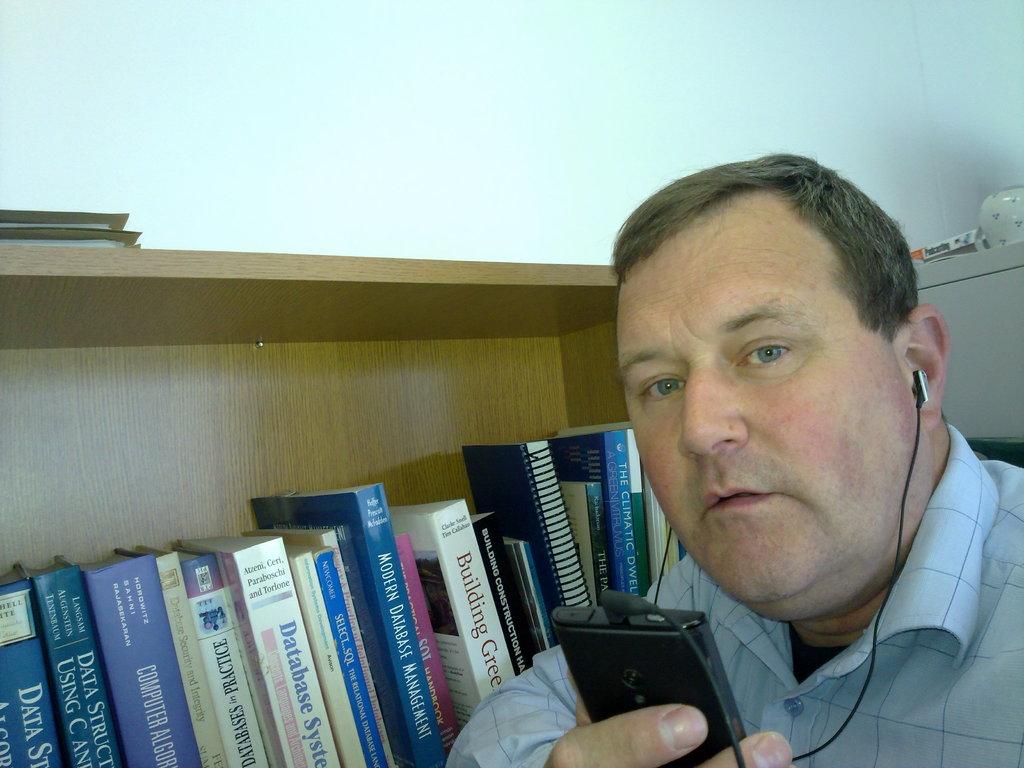What is the title of one of the books on the shelf?
Offer a terse response. Modern database management. What kind of database management can you learn about in the blue book?
Make the answer very short. Modern. 